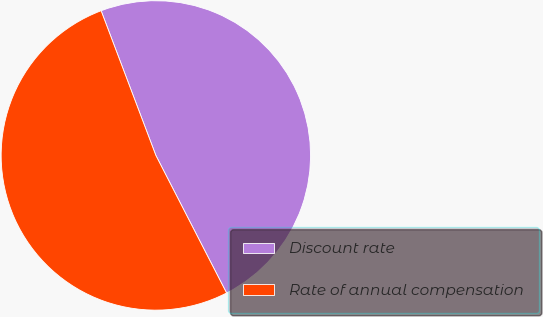Convert chart to OTSL. <chart><loc_0><loc_0><loc_500><loc_500><pie_chart><fcel>Discount rate<fcel>Rate of annual compensation<nl><fcel>48.2%<fcel>51.8%<nl></chart> 